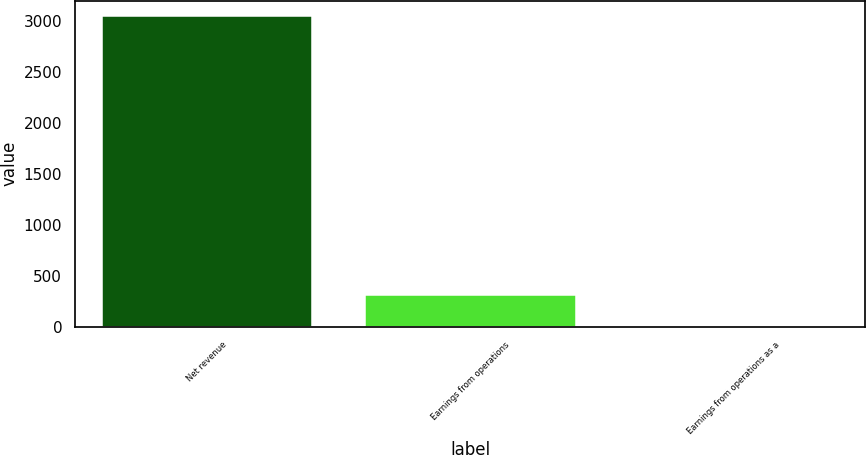Convert chart. <chart><loc_0><loc_0><loc_500><loc_500><bar_chart><fcel>Net revenue<fcel>Earnings from operations<fcel>Earnings from operations as a<nl><fcel>3047<fcel>312.98<fcel>9.2<nl></chart> 